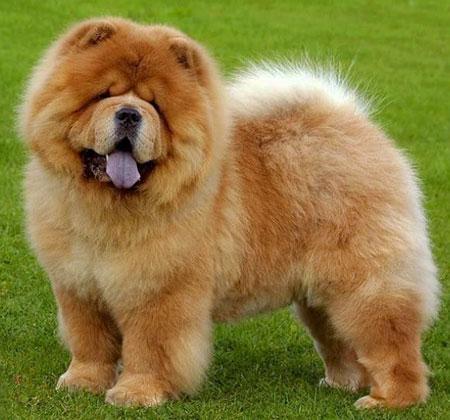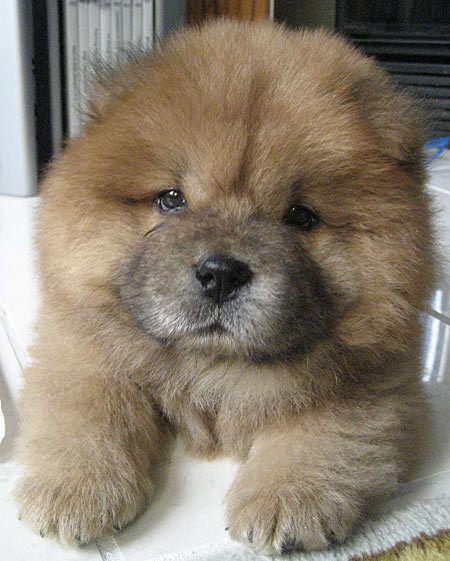The first image is the image on the left, the second image is the image on the right. Examine the images to the left and right. Is the description "Right and left images contain the same number of dogs." accurate? Answer yes or no. Yes. The first image is the image on the left, the second image is the image on the right. Given the left and right images, does the statement "There are two dogs in total." hold true? Answer yes or no. Yes. 